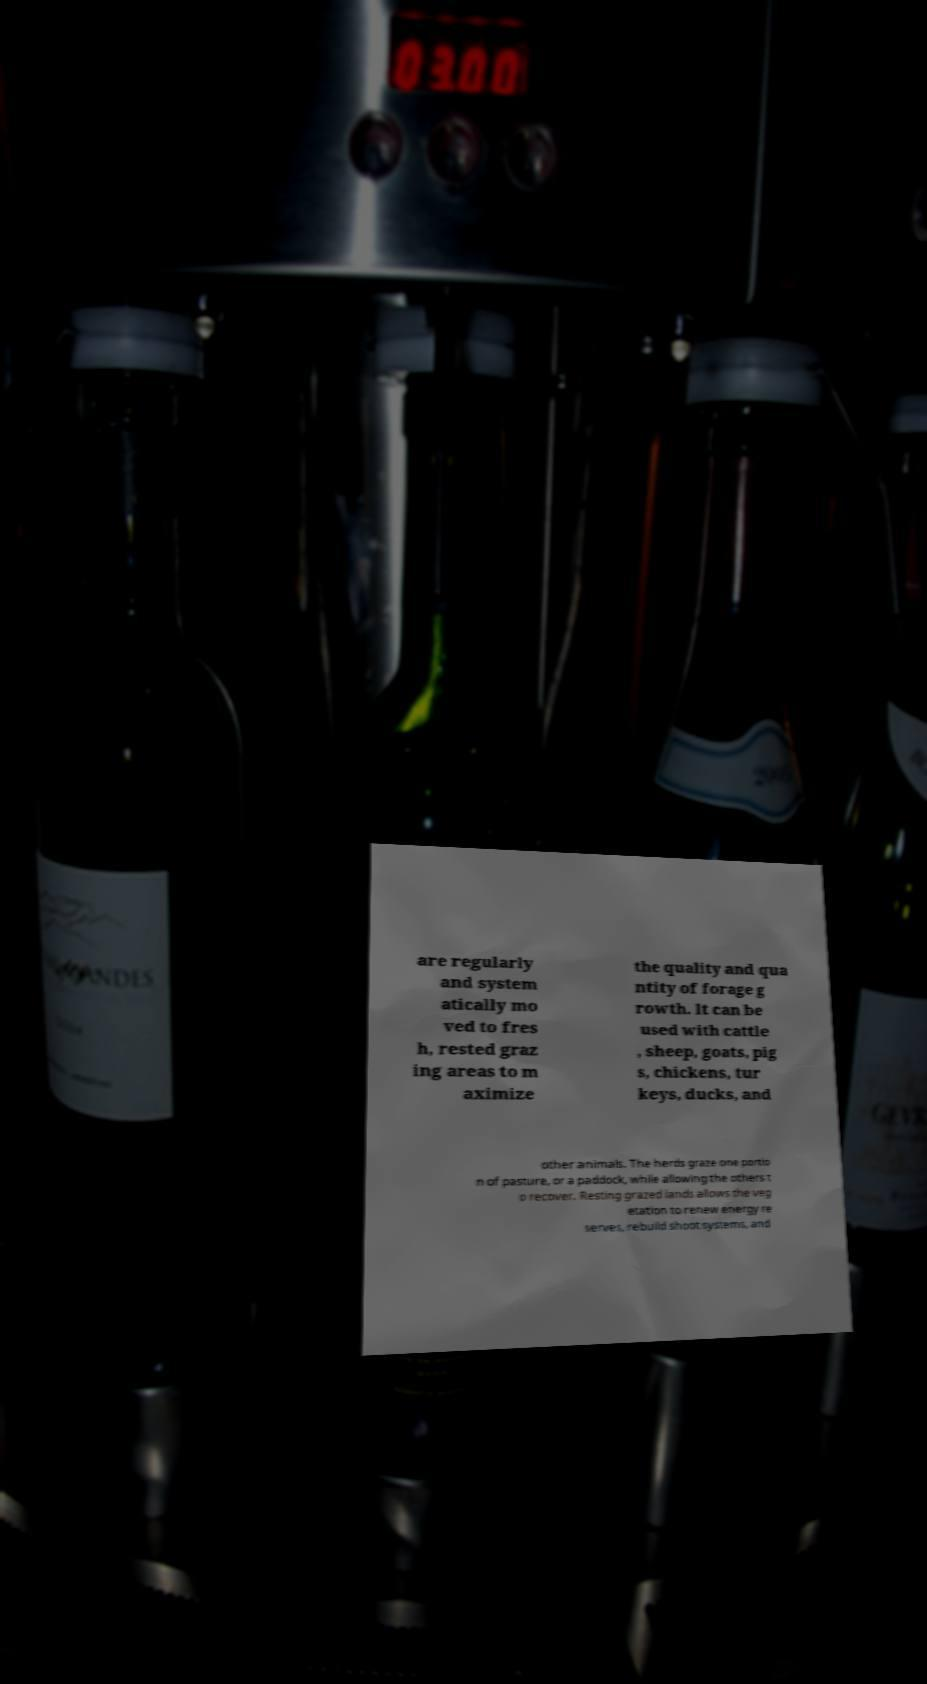Could you assist in decoding the text presented in this image and type it out clearly? are regularly and system atically mo ved to fres h, rested graz ing areas to m aximize the quality and qua ntity of forage g rowth. It can be used with cattle , sheep, goats, pig s, chickens, tur keys, ducks, and other animals. The herds graze one portio n of pasture, or a paddock, while allowing the others t o recover. Resting grazed lands allows the veg etation to renew energy re serves, rebuild shoot systems, and 